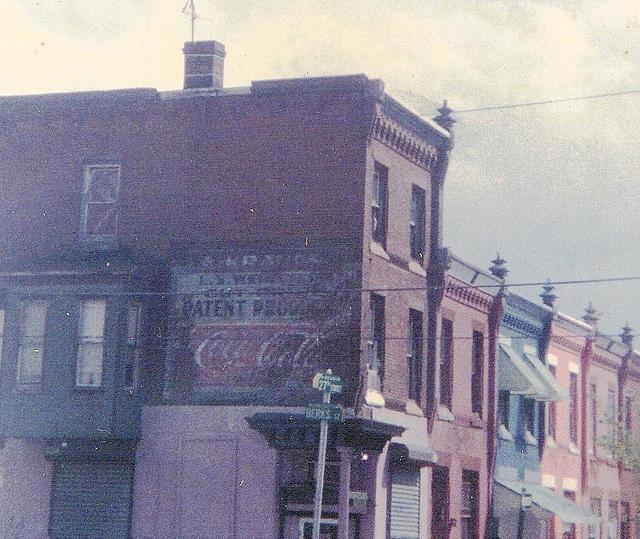How many buildings do you see?
Give a very brief answer. 6. 